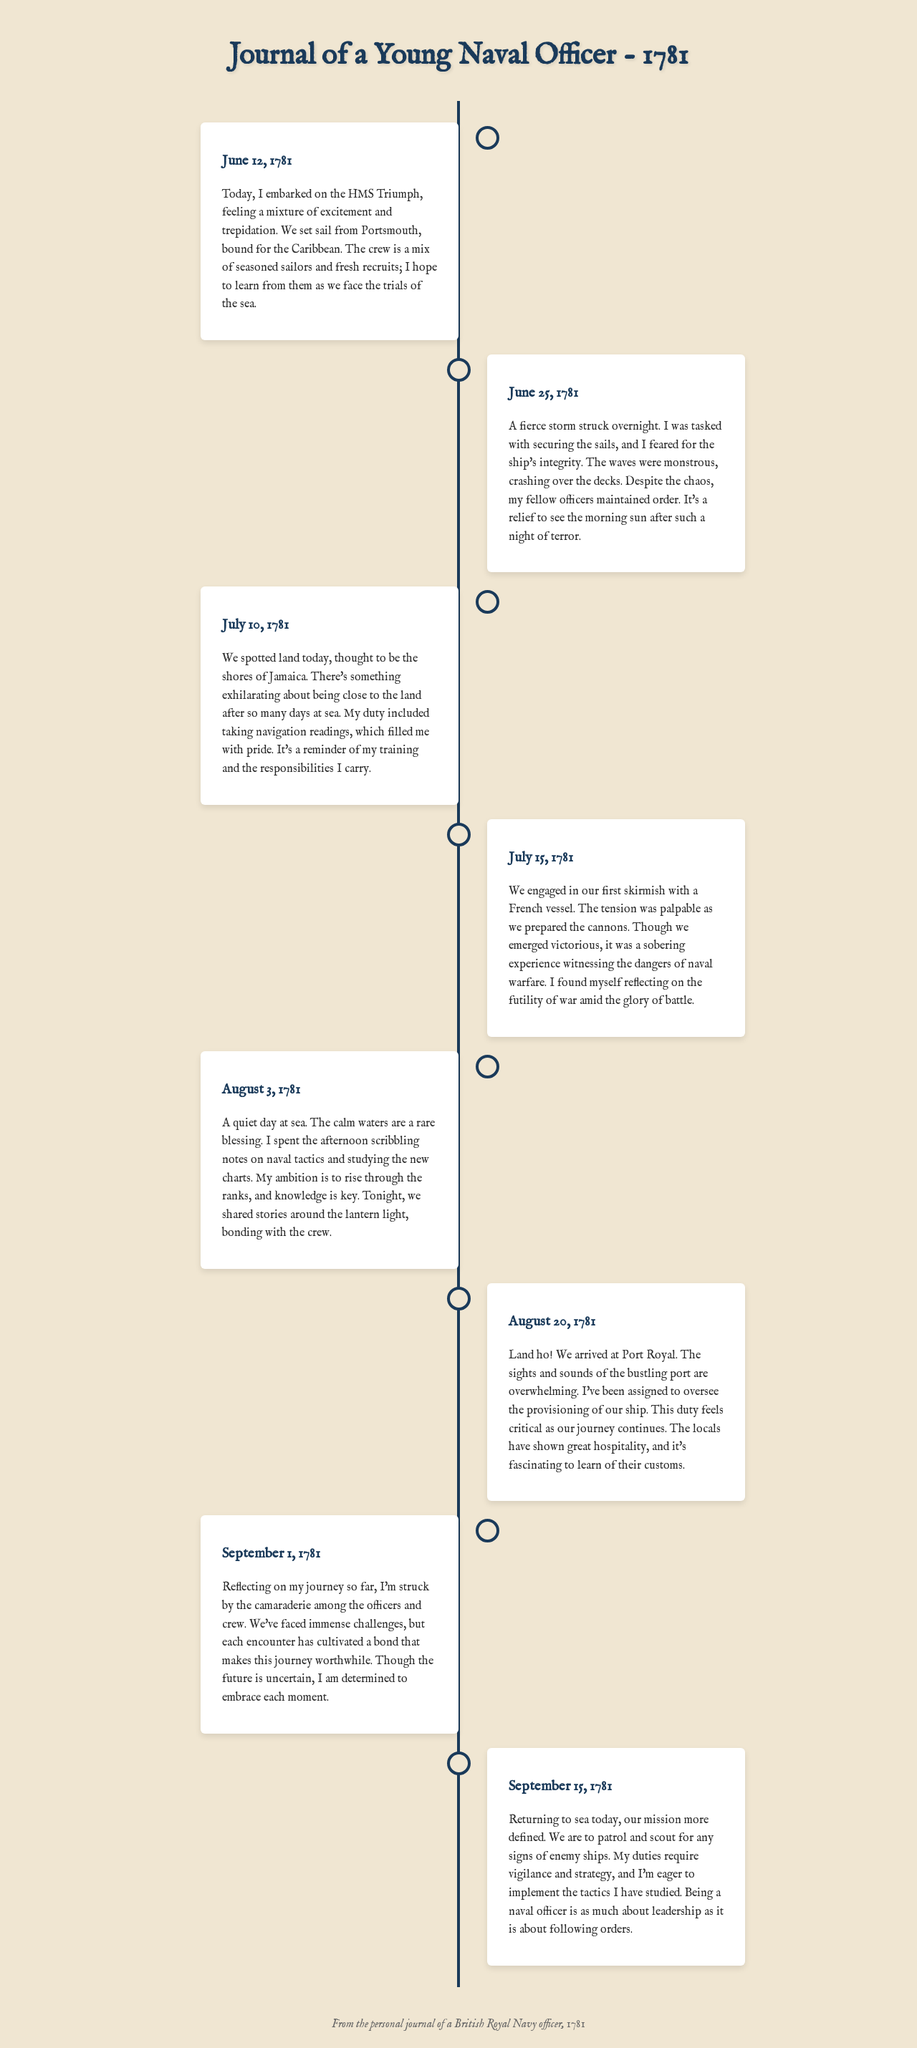What date did the officer embark on the HMS Triumph? The date of embarking on the HMS Triumph is explicitly mentioned in the first entry of the journal.
Answer: June 12, 1781 What was the first land spotted by the crew? The journal entry dated July 10, 1781, specifies the land sighted by the crew as Jamaica.
Answer: Jamaica What action did the crew take on July 15, 1781? The entry on July 15, 1781, describes the crew's engagement in skirmish with a French vessel.
Answer: Engaged in skirmish How many days passed between the first and second entry? The first entry is on June 12, 1781, and the second is on June 25, 1781, which can be calculated based on the dates.
Answer: 13 days What duty was assigned to the officer at Port Royal? The officer mentions their assignment regarding provisioning in the entry dated August 20, 1781.
Answer: Oversee provisioning What emotion does the officer express about their journey so far? In the September 1, 1781 entry, the officer reflects on the camaraderie among crew and expresses a positive sentiment.
Answer: Camaraderie What did the officer do during the calm day on August 3, 1781? The entry for August 3, 1781, discusses the officer's activities, which included studying naval tactics and new charts.
Answer: Studying naval tactics What is the primary focus of the officer's duties mentioned on September 15, 1781? The September 15, 1781 entry states that the officer's duties were to patrol and scout for enemy ships.
Answer: Patrol and scout 